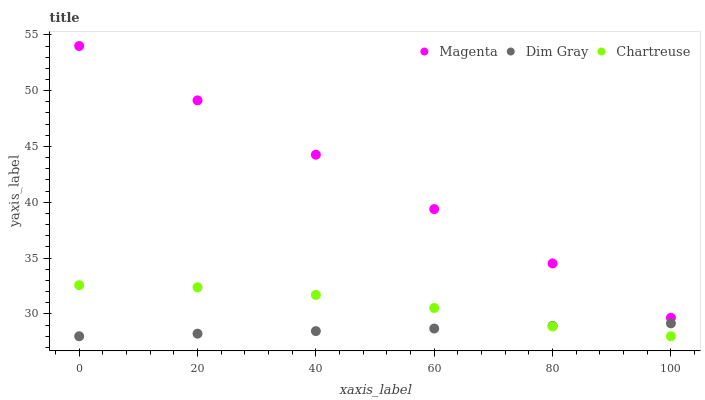Does Dim Gray have the minimum area under the curve?
Answer yes or no. Yes. Does Magenta have the maximum area under the curve?
Answer yes or no. Yes. Does Chartreuse have the minimum area under the curve?
Answer yes or no. No. Does Chartreuse have the maximum area under the curve?
Answer yes or no. No. Is Dim Gray the smoothest?
Answer yes or no. Yes. Is Chartreuse the roughest?
Answer yes or no. Yes. Is Chartreuse the smoothest?
Answer yes or no. No. Is Dim Gray the roughest?
Answer yes or no. No. Does Dim Gray have the lowest value?
Answer yes or no. Yes. Does Magenta have the highest value?
Answer yes or no. Yes. Does Chartreuse have the highest value?
Answer yes or no. No. Is Dim Gray less than Magenta?
Answer yes or no. Yes. Is Magenta greater than Dim Gray?
Answer yes or no. Yes. Does Dim Gray intersect Chartreuse?
Answer yes or no. Yes. Is Dim Gray less than Chartreuse?
Answer yes or no. No. Is Dim Gray greater than Chartreuse?
Answer yes or no. No. Does Dim Gray intersect Magenta?
Answer yes or no. No. 